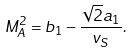Convert formula to latex. <formula><loc_0><loc_0><loc_500><loc_500>M _ { A } ^ { 2 } = b _ { 1 } - \frac { \sqrt { 2 } a _ { 1 } } { v _ { S } } .</formula> 